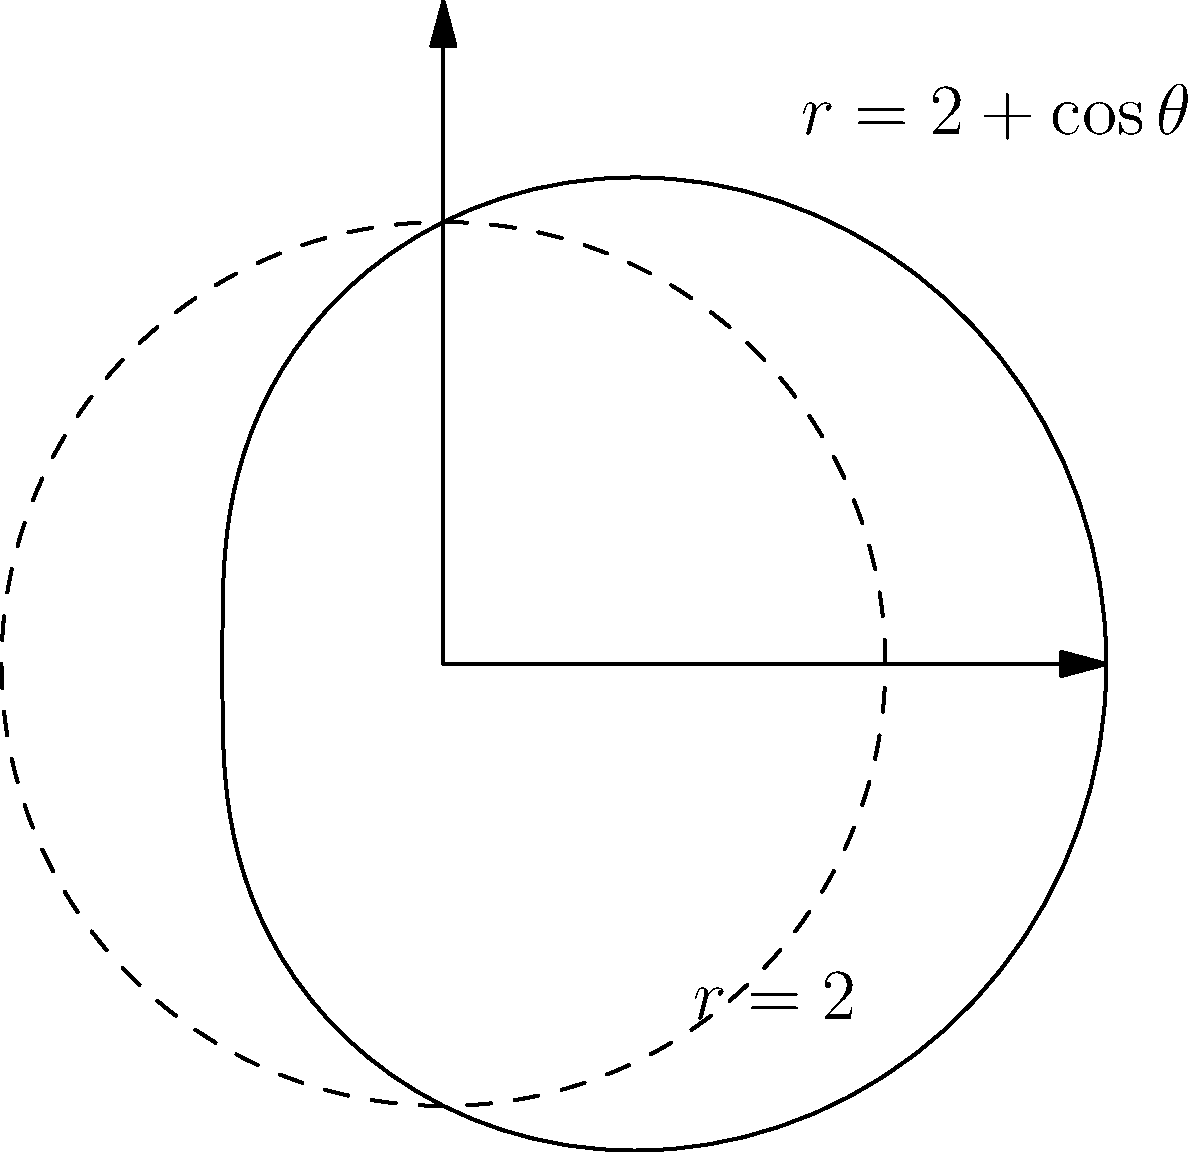A new industrial vacuum cleaner model has an effective cleaning radius that varies based on its angle of operation. The radius $r$ (in meters) is given by the polar equation $r = 2 + \cos\theta$, where $\theta$ is the angle in radians. Calculate the total area (in square meters) that this vacuum cleaner can clean in one complete revolution. To find the total area cleaned by the vacuum cleaner, we need to calculate the area enclosed by the polar curve $r = 2 + \cos\theta$ for one complete revolution (0 to $2\pi$).

Step 1: The formula for the area enclosed by a polar curve is:
$$A = \frac{1}{2} \int_{0}^{2\pi} r^2 d\theta$$

Step 2: Substitute the given equation $r = 2 + \cos\theta$ into the formula:
$$A = \frac{1}{2} \int_{0}^{2\pi} (2 + \cos\theta)^2 d\theta$$

Step 3: Expand the squared term:
$$A = \frac{1}{2} \int_{0}^{2\pi} (4 + 4\cos\theta + \cos^2\theta) d\theta$$

Step 4: Integrate each term:
$$A = \frac{1}{2} \left[4\theta + 4\sin\theta + \frac{1}{2}\theta + \frac{1}{4}\sin(2\theta)\right]_{0}^{2\pi}$$

Step 5: Evaluate the integral:
$$A = \frac{1}{2} \left[(4 \cdot 2\pi + 0 + \frac{1}{2} \cdot 2\pi + 0) - (0 + 0 + 0 + 0)\right]$$

Step 6: Simplify:
$$A = \frac{1}{2} \left(8\pi + \pi\right) = \frac{9\pi}{2}$$

Therefore, the total area cleaned by the vacuum cleaner in one complete revolution is $\frac{9\pi}{2}$ square meters.
Answer: $\frac{9\pi}{2}$ m² 